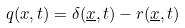<formula> <loc_0><loc_0><loc_500><loc_500>q ( x , t ) = \delta ( \underline { x } , t ) - r ( \underline { x } , t )</formula> 